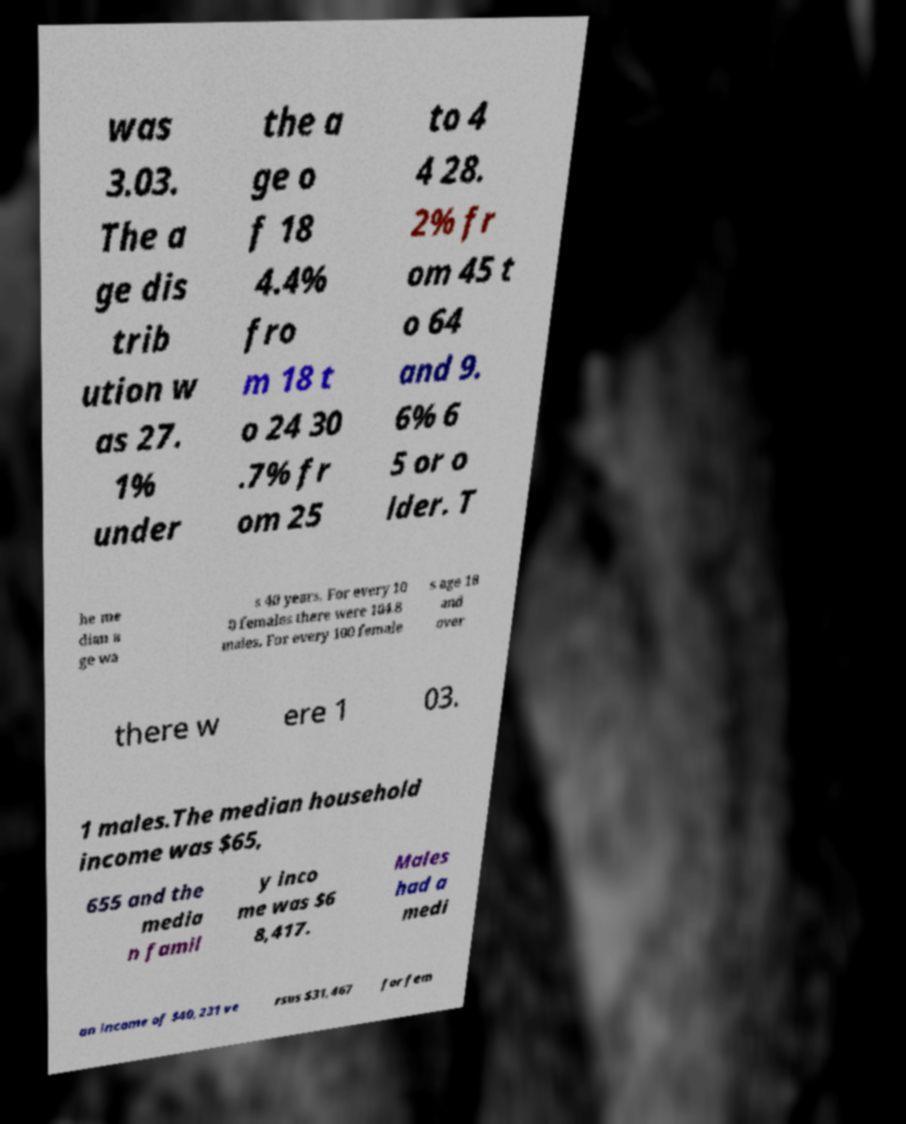Can you read and provide the text displayed in the image?This photo seems to have some interesting text. Can you extract and type it out for me? was 3.03. The a ge dis trib ution w as 27. 1% under the a ge o f 18 4.4% fro m 18 t o 24 30 .7% fr om 25 to 4 4 28. 2% fr om 45 t o 64 and 9. 6% 6 5 or o lder. T he me dian a ge wa s 40 years. For every 10 0 females there were 104.8 males. For every 100 female s age 18 and over there w ere 1 03. 1 males.The median household income was $65, 655 and the media n famil y inco me was $6 8,417. Males had a medi an income of $40,231 ve rsus $31,467 for fem 